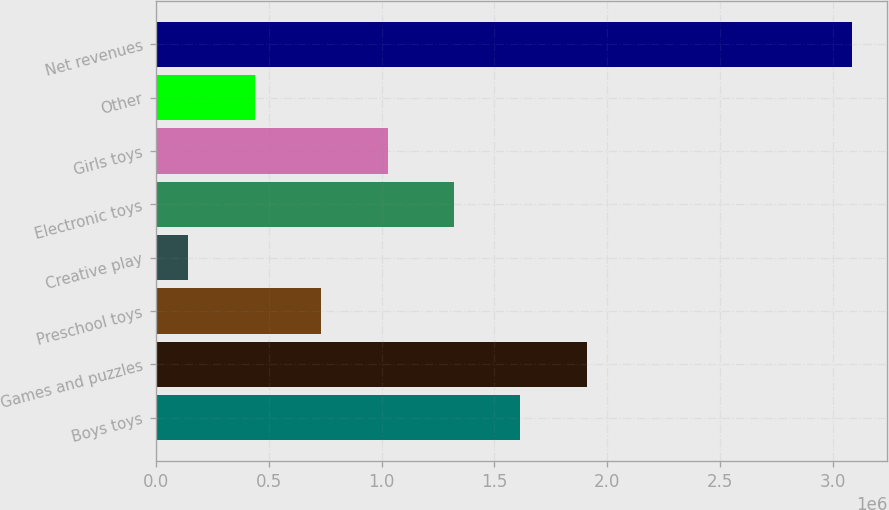Convert chart to OTSL. <chart><loc_0><loc_0><loc_500><loc_500><bar_chart><fcel>Boys toys<fcel>Games and puzzles<fcel>Preschool toys<fcel>Creative play<fcel>Electronic toys<fcel>Girls toys<fcel>Other<fcel>Net revenues<nl><fcel>1.61511e+06<fcel>1.90962e+06<fcel>731605<fcel>142600<fcel>1.32061e+06<fcel>1.02611e+06<fcel>437103<fcel>3.08763e+06<nl></chart> 